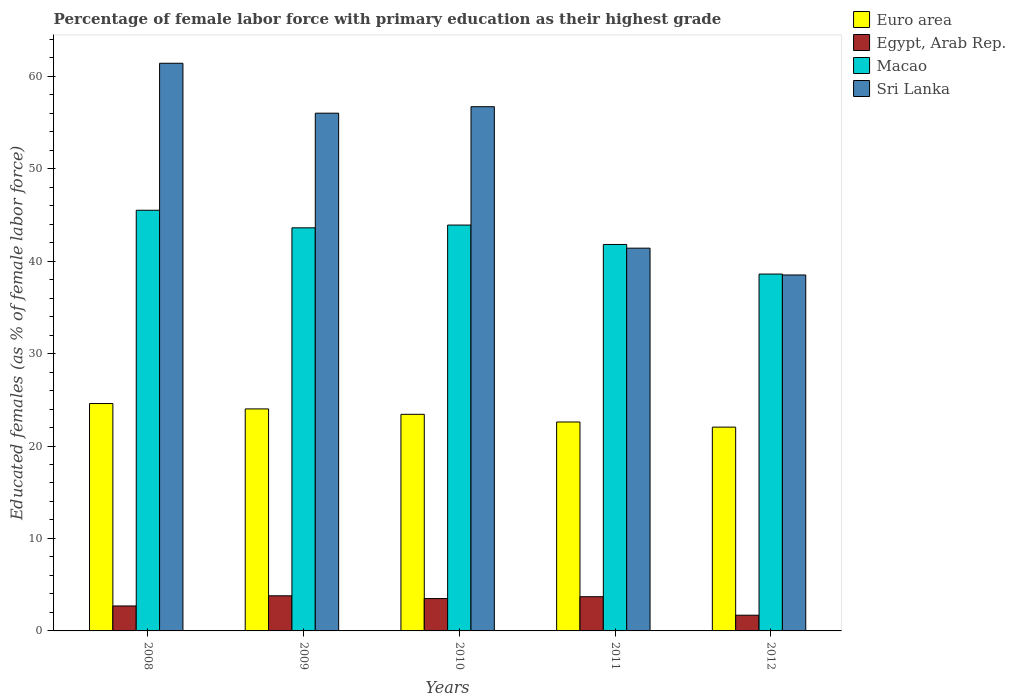How many different coloured bars are there?
Offer a very short reply. 4. Are the number of bars on each tick of the X-axis equal?
Your answer should be compact. Yes. What is the label of the 3rd group of bars from the left?
Your answer should be compact. 2010. What is the percentage of female labor force with primary education in Egypt, Arab Rep. in 2011?
Your answer should be compact. 3.7. Across all years, what is the maximum percentage of female labor force with primary education in Sri Lanka?
Ensure brevity in your answer.  61.4. Across all years, what is the minimum percentage of female labor force with primary education in Euro area?
Provide a short and direct response. 22.04. In which year was the percentage of female labor force with primary education in Egypt, Arab Rep. maximum?
Your response must be concise. 2009. In which year was the percentage of female labor force with primary education in Sri Lanka minimum?
Give a very brief answer. 2012. What is the total percentage of female labor force with primary education in Euro area in the graph?
Give a very brief answer. 116.68. What is the difference between the percentage of female labor force with primary education in Macao in 2009 and that in 2011?
Offer a terse response. 1.8. What is the difference between the percentage of female labor force with primary education in Sri Lanka in 2011 and the percentage of female labor force with primary education in Macao in 2008?
Your response must be concise. -4.1. What is the average percentage of female labor force with primary education in Macao per year?
Keep it short and to the point. 42.68. In the year 2012, what is the difference between the percentage of female labor force with primary education in Euro area and percentage of female labor force with primary education in Egypt, Arab Rep.?
Provide a succinct answer. 20.34. In how many years, is the percentage of female labor force with primary education in Sri Lanka greater than 40 %?
Offer a terse response. 4. What is the ratio of the percentage of female labor force with primary education in Macao in 2011 to that in 2012?
Your response must be concise. 1.08. Is the percentage of female labor force with primary education in Sri Lanka in 2010 less than that in 2012?
Provide a succinct answer. No. Is the difference between the percentage of female labor force with primary education in Euro area in 2010 and 2012 greater than the difference between the percentage of female labor force with primary education in Egypt, Arab Rep. in 2010 and 2012?
Provide a short and direct response. No. What is the difference between the highest and the second highest percentage of female labor force with primary education in Macao?
Keep it short and to the point. 1.6. What is the difference between the highest and the lowest percentage of female labor force with primary education in Sri Lanka?
Offer a very short reply. 22.9. Is the sum of the percentage of female labor force with primary education in Sri Lanka in 2009 and 2011 greater than the maximum percentage of female labor force with primary education in Egypt, Arab Rep. across all years?
Your answer should be very brief. Yes. Is it the case that in every year, the sum of the percentage of female labor force with primary education in Sri Lanka and percentage of female labor force with primary education in Euro area is greater than the percentage of female labor force with primary education in Egypt, Arab Rep.?
Offer a terse response. Yes. Are all the bars in the graph horizontal?
Provide a succinct answer. No. How many years are there in the graph?
Ensure brevity in your answer.  5. How many legend labels are there?
Your answer should be very brief. 4. How are the legend labels stacked?
Give a very brief answer. Vertical. What is the title of the graph?
Ensure brevity in your answer.  Percentage of female labor force with primary education as their highest grade. What is the label or title of the Y-axis?
Provide a short and direct response. Educated females (as % of female labor force). What is the Educated females (as % of female labor force) in Euro area in 2008?
Give a very brief answer. 24.59. What is the Educated females (as % of female labor force) of Egypt, Arab Rep. in 2008?
Your answer should be very brief. 2.7. What is the Educated females (as % of female labor force) in Macao in 2008?
Offer a very short reply. 45.5. What is the Educated females (as % of female labor force) of Sri Lanka in 2008?
Give a very brief answer. 61.4. What is the Educated females (as % of female labor force) in Euro area in 2009?
Your answer should be very brief. 24.01. What is the Educated females (as % of female labor force) of Egypt, Arab Rep. in 2009?
Provide a succinct answer. 3.8. What is the Educated females (as % of female labor force) in Macao in 2009?
Offer a very short reply. 43.6. What is the Educated females (as % of female labor force) in Euro area in 2010?
Offer a very short reply. 23.43. What is the Educated females (as % of female labor force) in Macao in 2010?
Ensure brevity in your answer.  43.9. What is the Educated females (as % of female labor force) of Sri Lanka in 2010?
Give a very brief answer. 56.7. What is the Educated females (as % of female labor force) of Euro area in 2011?
Provide a short and direct response. 22.6. What is the Educated females (as % of female labor force) in Egypt, Arab Rep. in 2011?
Keep it short and to the point. 3.7. What is the Educated females (as % of female labor force) in Macao in 2011?
Give a very brief answer. 41.8. What is the Educated females (as % of female labor force) of Sri Lanka in 2011?
Provide a short and direct response. 41.4. What is the Educated females (as % of female labor force) of Euro area in 2012?
Your response must be concise. 22.04. What is the Educated females (as % of female labor force) of Egypt, Arab Rep. in 2012?
Your answer should be very brief. 1.7. What is the Educated females (as % of female labor force) of Macao in 2012?
Offer a terse response. 38.6. What is the Educated females (as % of female labor force) of Sri Lanka in 2012?
Offer a very short reply. 38.5. Across all years, what is the maximum Educated females (as % of female labor force) in Euro area?
Give a very brief answer. 24.59. Across all years, what is the maximum Educated females (as % of female labor force) of Egypt, Arab Rep.?
Offer a terse response. 3.8. Across all years, what is the maximum Educated females (as % of female labor force) in Macao?
Offer a terse response. 45.5. Across all years, what is the maximum Educated females (as % of female labor force) of Sri Lanka?
Your response must be concise. 61.4. Across all years, what is the minimum Educated females (as % of female labor force) in Euro area?
Keep it short and to the point. 22.04. Across all years, what is the minimum Educated females (as % of female labor force) of Egypt, Arab Rep.?
Your answer should be very brief. 1.7. Across all years, what is the minimum Educated females (as % of female labor force) of Macao?
Offer a very short reply. 38.6. Across all years, what is the minimum Educated females (as % of female labor force) of Sri Lanka?
Provide a short and direct response. 38.5. What is the total Educated females (as % of female labor force) of Euro area in the graph?
Make the answer very short. 116.68. What is the total Educated females (as % of female labor force) of Macao in the graph?
Your answer should be very brief. 213.4. What is the total Educated females (as % of female labor force) of Sri Lanka in the graph?
Provide a short and direct response. 254. What is the difference between the Educated females (as % of female labor force) in Euro area in 2008 and that in 2009?
Your response must be concise. 0.58. What is the difference between the Educated females (as % of female labor force) in Egypt, Arab Rep. in 2008 and that in 2009?
Your answer should be very brief. -1.1. What is the difference between the Educated females (as % of female labor force) of Macao in 2008 and that in 2009?
Ensure brevity in your answer.  1.9. What is the difference between the Educated females (as % of female labor force) of Sri Lanka in 2008 and that in 2009?
Ensure brevity in your answer.  5.4. What is the difference between the Educated females (as % of female labor force) of Euro area in 2008 and that in 2010?
Your answer should be compact. 1.17. What is the difference between the Educated females (as % of female labor force) in Egypt, Arab Rep. in 2008 and that in 2010?
Ensure brevity in your answer.  -0.8. What is the difference between the Educated females (as % of female labor force) of Euro area in 2008 and that in 2011?
Keep it short and to the point. 1.99. What is the difference between the Educated females (as % of female labor force) in Egypt, Arab Rep. in 2008 and that in 2011?
Keep it short and to the point. -1. What is the difference between the Educated females (as % of female labor force) of Macao in 2008 and that in 2011?
Ensure brevity in your answer.  3.7. What is the difference between the Educated females (as % of female labor force) in Sri Lanka in 2008 and that in 2011?
Give a very brief answer. 20. What is the difference between the Educated females (as % of female labor force) in Euro area in 2008 and that in 2012?
Provide a short and direct response. 2.55. What is the difference between the Educated females (as % of female labor force) of Egypt, Arab Rep. in 2008 and that in 2012?
Offer a terse response. 1. What is the difference between the Educated females (as % of female labor force) of Sri Lanka in 2008 and that in 2012?
Ensure brevity in your answer.  22.9. What is the difference between the Educated females (as % of female labor force) in Euro area in 2009 and that in 2010?
Offer a very short reply. 0.58. What is the difference between the Educated females (as % of female labor force) of Egypt, Arab Rep. in 2009 and that in 2010?
Offer a very short reply. 0.3. What is the difference between the Educated females (as % of female labor force) in Euro area in 2009 and that in 2011?
Offer a terse response. 1.41. What is the difference between the Educated females (as % of female labor force) in Egypt, Arab Rep. in 2009 and that in 2011?
Keep it short and to the point. 0.1. What is the difference between the Educated females (as % of female labor force) in Macao in 2009 and that in 2011?
Your answer should be very brief. 1.8. What is the difference between the Educated females (as % of female labor force) in Sri Lanka in 2009 and that in 2011?
Make the answer very short. 14.6. What is the difference between the Educated females (as % of female labor force) in Euro area in 2009 and that in 2012?
Your answer should be very brief. 1.97. What is the difference between the Educated females (as % of female labor force) in Egypt, Arab Rep. in 2009 and that in 2012?
Give a very brief answer. 2.1. What is the difference between the Educated females (as % of female labor force) of Sri Lanka in 2009 and that in 2012?
Give a very brief answer. 17.5. What is the difference between the Educated females (as % of female labor force) in Euro area in 2010 and that in 2011?
Provide a short and direct response. 0.83. What is the difference between the Educated females (as % of female labor force) in Euro area in 2010 and that in 2012?
Ensure brevity in your answer.  1.38. What is the difference between the Educated females (as % of female labor force) in Sri Lanka in 2010 and that in 2012?
Offer a terse response. 18.2. What is the difference between the Educated females (as % of female labor force) in Euro area in 2011 and that in 2012?
Keep it short and to the point. 0.55. What is the difference between the Educated females (as % of female labor force) of Sri Lanka in 2011 and that in 2012?
Keep it short and to the point. 2.9. What is the difference between the Educated females (as % of female labor force) of Euro area in 2008 and the Educated females (as % of female labor force) of Egypt, Arab Rep. in 2009?
Your answer should be very brief. 20.79. What is the difference between the Educated females (as % of female labor force) in Euro area in 2008 and the Educated females (as % of female labor force) in Macao in 2009?
Make the answer very short. -19.01. What is the difference between the Educated females (as % of female labor force) of Euro area in 2008 and the Educated females (as % of female labor force) of Sri Lanka in 2009?
Give a very brief answer. -31.41. What is the difference between the Educated females (as % of female labor force) of Egypt, Arab Rep. in 2008 and the Educated females (as % of female labor force) of Macao in 2009?
Your answer should be very brief. -40.9. What is the difference between the Educated females (as % of female labor force) in Egypt, Arab Rep. in 2008 and the Educated females (as % of female labor force) in Sri Lanka in 2009?
Your answer should be very brief. -53.3. What is the difference between the Educated females (as % of female labor force) of Euro area in 2008 and the Educated females (as % of female labor force) of Egypt, Arab Rep. in 2010?
Your response must be concise. 21.09. What is the difference between the Educated females (as % of female labor force) of Euro area in 2008 and the Educated females (as % of female labor force) of Macao in 2010?
Your response must be concise. -19.31. What is the difference between the Educated females (as % of female labor force) of Euro area in 2008 and the Educated females (as % of female labor force) of Sri Lanka in 2010?
Provide a succinct answer. -32.11. What is the difference between the Educated females (as % of female labor force) of Egypt, Arab Rep. in 2008 and the Educated females (as % of female labor force) of Macao in 2010?
Provide a short and direct response. -41.2. What is the difference between the Educated females (as % of female labor force) of Egypt, Arab Rep. in 2008 and the Educated females (as % of female labor force) of Sri Lanka in 2010?
Offer a terse response. -54. What is the difference between the Educated females (as % of female labor force) in Macao in 2008 and the Educated females (as % of female labor force) in Sri Lanka in 2010?
Your answer should be compact. -11.2. What is the difference between the Educated females (as % of female labor force) of Euro area in 2008 and the Educated females (as % of female labor force) of Egypt, Arab Rep. in 2011?
Offer a very short reply. 20.89. What is the difference between the Educated females (as % of female labor force) in Euro area in 2008 and the Educated females (as % of female labor force) in Macao in 2011?
Offer a very short reply. -17.21. What is the difference between the Educated females (as % of female labor force) of Euro area in 2008 and the Educated females (as % of female labor force) of Sri Lanka in 2011?
Offer a terse response. -16.81. What is the difference between the Educated females (as % of female labor force) in Egypt, Arab Rep. in 2008 and the Educated females (as % of female labor force) in Macao in 2011?
Give a very brief answer. -39.1. What is the difference between the Educated females (as % of female labor force) in Egypt, Arab Rep. in 2008 and the Educated females (as % of female labor force) in Sri Lanka in 2011?
Provide a short and direct response. -38.7. What is the difference between the Educated females (as % of female labor force) of Euro area in 2008 and the Educated females (as % of female labor force) of Egypt, Arab Rep. in 2012?
Ensure brevity in your answer.  22.89. What is the difference between the Educated females (as % of female labor force) of Euro area in 2008 and the Educated females (as % of female labor force) of Macao in 2012?
Provide a short and direct response. -14.01. What is the difference between the Educated females (as % of female labor force) of Euro area in 2008 and the Educated females (as % of female labor force) of Sri Lanka in 2012?
Provide a succinct answer. -13.91. What is the difference between the Educated females (as % of female labor force) in Egypt, Arab Rep. in 2008 and the Educated females (as % of female labor force) in Macao in 2012?
Keep it short and to the point. -35.9. What is the difference between the Educated females (as % of female labor force) of Egypt, Arab Rep. in 2008 and the Educated females (as % of female labor force) of Sri Lanka in 2012?
Your response must be concise. -35.8. What is the difference between the Educated females (as % of female labor force) of Macao in 2008 and the Educated females (as % of female labor force) of Sri Lanka in 2012?
Keep it short and to the point. 7. What is the difference between the Educated females (as % of female labor force) in Euro area in 2009 and the Educated females (as % of female labor force) in Egypt, Arab Rep. in 2010?
Keep it short and to the point. 20.51. What is the difference between the Educated females (as % of female labor force) in Euro area in 2009 and the Educated females (as % of female labor force) in Macao in 2010?
Your answer should be very brief. -19.89. What is the difference between the Educated females (as % of female labor force) of Euro area in 2009 and the Educated females (as % of female labor force) of Sri Lanka in 2010?
Your answer should be very brief. -32.69. What is the difference between the Educated females (as % of female labor force) in Egypt, Arab Rep. in 2009 and the Educated females (as % of female labor force) in Macao in 2010?
Give a very brief answer. -40.1. What is the difference between the Educated females (as % of female labor force) in Egypt, Arab Rep. in 2009 and the Educated females (as % of female labor force) in Sri Lanka in 2010?
Give a very brief answer. -52.9. What is the difference between the Educated females (as % of female labor force) in Macao in 2009 and the Educated females (as % of female labor force) in Sri Lanka in 2010?
Your answer should be very brief. -13.1. What is the difference between the Educated females (as % of female labor force) in Euro area in 2009 and the Educated females (as % of female labor force) in Egypt, Arab Rep. in 2011?
Offer a terse response. 20.31. What is the difference between the Educated females (as % of female labor force) of Euro area in 2009 and the Educated females (as % of female labor force) of Macao in 2011?
Provide a succinct answer. -17.79. What is the difference between the Educated females (as % of female labor force) in Euro area in 2009 and the Educated females (as % of female labor force) in Sri Lanka in 2011?
Offer a very short reply. -17.39. What is the difference between the Educated females (as % of female labor force) of Egypt, Arab Rep. in 2009 and the Educated females (as % of female labor force) of Macao in 2011?
Your response must be concise. -38. What is the difference between the Educated females (as % of female labor force) in Egypt, Arab Rep. in 2009 and the Educated females (as % of female labor force) in Sri Lanka in 2011?
Your answer should be compact. -37.6. What is the difference between the Educated females (as % of female labor force) of Euro area in 2009 and the Educated females (as % of female labor force) of Egypt, Arab Rep. in 2012?
Your answer should be very brief. 22.31. What is the difference between the Educated females (as % of female labor force) in Euro area in 2009 and the Educated females (as % of female labor force) in Macao in 2012?
Your answer should be compact. -14.59. What is the difference between the Educated females (as % of female labor force) of Euro area in 2009 and the Educated females (as % of female labor force) of Sri Lanka in 2012?
Ensure brevity in your answer.  -14.49. What is the difference between the Educated females (as % of female labor force) in Egypt, Arab Rep. in 2009 and the Educated females (as % of female labor force) in Macao in 2012?
Your answer should be compact. -34.8. What is the difference between the Educated females (as % of female labor force) of Egypt, Arab Rep. in 2009 and the Educated females (as % of female labor force) of Sri Lanka in 2012?
Offer a terse response. -34.7. What is the difference between the Educated females (as % of female labor force) in Euro area in 2010 and the Educated females (as % of female labor force) in Egypt, Arab Rep. in 2011?
Provide a short and direct response. 19.73. What is the difference between the Educated females (as % of female labor force) in Euro area in 2010 and the Educated females (as % of female labor force) in Macao in 2011?
Your response must be concise. -18.37. What is the difference between the Educated females (as % of female labor force) of Euro area in 2010 and the Educated females (as % of female labor force) of Sri Lanka in 2011?
Give a very brief answer. -17.97. What is the difference between the Educated females (as % of female labor force) of Egypt, Arab Rep. in 2010 and the Educated females (as % of female labor force) of Macao in 2011?
Offer a very short reply. -38.3. What is the difference between the Educated females (as % of female labor force) of Egypt, Arab Rep. in 2010 and the Educated females (as % of female labor force) of Sri Lanka in 2011?
Offer a terse response. -37.9. What is the difference between the Educated females (as % of female labor force) in Euro area in 2010 and the Educated females (as % of female labor force) in Egypt, Arab Rep. in 2012?
Keep it short and to the point. 21.73. What is the difference between the Educated females (as % of female labor force) of Euro area in 2010 and the Educated females (as % of female labor force) of Macao in 2012?
Offer a very short reply. -15.17. What is the difference between the Educated females (as % of female labor force) of Euro area in 2010 and the Educated females (as % of female labor force) of Sri Lanka in 2012?
Make the answer very short. -15.07. What is the difference between the Educated females (as % of female labor force) of Egypt, Arab Rep. in 2010 and the Educated females (as % of female labor force) of Macao in 2012?
Provide a succinct answer. -35.1. What is the difference between the Educated females (as % of female labor force) of Egypt, Arab Rep. in 2010 and the Educated females (as % of female labor force) of Sri Lanka in 2012?
Provide a short and direct response. -35. What is the difference between the Educated females (as % of female labor force) in Euro area in 2011 and the Educated females (as % of female labor force) in Egypt, Arab Rep. in 2012?
Your response must be concise. 20.9. What is the difference between the Educated females (as % of female labor force) of Euro area in 2011 and the Educated females (as % of female labor force) of Macao in 2012?
Ensure brevity in your answer.  -16. What is the difference between the Educated females (as % of female labor force) in Euro area in 2011 and the Educated females (as % of female labor force) in Sri Lanka in 2012?
Give a very brief answer. -15.9. What is the difference between the Educated females (as % of female labor force) of Egypt, Arab Rep. in 2011 and the Educated females (as % of female labor force) of Macao in 2012?
Your response must be concise. -34.9. What is the difference between the Educated females (as % of female labor force) in Egypt, Arab Rep. in 2011 and the Educated females (as % of female labor force) in Sri Lanka in 2012?
Give a very brief answer. -34.8. What is the average Educated females (as % of female labor force) of Euro area per year?
Your answer should be very brief. 23.34. What is the average Educated females (as % of female labor force) of Egypt, Arab Rep. per year?
Give a very brief answer. 3.08. What is the average Educated females (as % of female labor force) in Macao per year?
Make the answer very short. 42.68. What is the average Educated females (as % of female labor force) of Sri Lanka per year?
Offer a terse response. 50.8. In the year 2008, what is the difference between the Educated females (as % of female labor force) of Euro area and Educated females (as % of female labor force) of Egypt, Arab Rep.?
Provide a succinct answer. 21.89. In the year 2008, what is the difference between the Educated females (as % of female labor force) in Euro area and Educated females (as % of female labor force) in Macao?
Your answer should be very brief. -20.91. In the year 2008, what is the difference between the Educated females (as % of female labor force) of Euro area and Educated females (as % of female labor force) of Sri Lanka?
Keep it short and to the point. -36.81. In the year 2008, what is the difference between the Educated females (as % of female labor force) in Egypt, Arab Rep. and Educated females (as % of female labor force) in Macao?
Your answer should be compact. -42.8. In the year 2008, what is the difference between the Educated females (as % of female labor force) of Egypt, Arab Rep. and Educated females (as % of female labor force) of Sri Lanka?
Your answer should be very brief. -58.7. In the year 2008, what is the difference between the Educated females (as % of female labor force) in Macao and Educated females (as % of female labor force) in Sri Lanka?
Your answer should be compact. -15.9. In the year 2009, what is the difference between the Educated females (as % of female labor force) of Euro area and Educated females (as % of female labor force) of Egypt, Arab Rep.?
Ensure brevity in your answer.  20.21. In the year 2009, what is the difference between the Educated females (as % of female labor force) of Euro area and Educated females (as % of female labor force) of Macao?
Keep it short and to the point. -19.59. In the year 2009, what is the difference between the Educated females (as % of female labor force) in Euro area and Educated females (as % of female labor force) in Sri Lanka?
Provide a succinct answer. -31.99. In the year 2009, what is the difference between the Educated females (as % of female labor force) of Egypt, Arab Rep. and Educated females (as % of female labor force) of Macao?
Offer a very short reply. -39.8. In the year 2009, what is the difference between the Educated females (as % of female labor force) of Egypt, Arab Rep. and Educated females (as % of female labor force) of Sri Lanka?
Keep it short and to the point. -52.2. In the year 2010, what is the difference between the Educated females (as % of female labor force) of Euro area and Educated females (as % of female labor force) of Egypt, Arab Rep.?
Give a very brief answer. 19.93. In the year 2010, what is the difference between the Educated females (as % of female labor force) of Euro area and Educated females (as % of female labor force) of Macao?
Offer a terse response. -20.47. In the year 2010, what is the difference between the Educated females (as % of female labor force) in Euro area and Educated females (as % of female labor force) in Sri Lanka?
Provide a succinct answer. -33.27. In the year 2010, what is the difference between the Educated females (as % of female labor force) of Egypt, Arab Rep. and Educated females (as % of female labor force) of Macao?
Provide a short and direct response. -40.4. In the year 2010, what is the difference between the Educated females (as % of female labor force) of Egypt, Arab Rep. and Educated females (as % of female labor force) of Sri Lanka?
Provide a short and direct response. -53.2. In the year 2010, what is the difference between the Educated females (as % of female labor force) in Macao and Educated females (as % of female labor force) in Sri Lanka?
Provide a short and direct response. -12.8. In the year 2011, what is the difference between the Educated females (as % of female labor force) of Euro area and Educated females (as % of female labor force) of Egypt, Arab Rep.?
Ensure brevity in your answer.  18.9. In the year 2011, what is the difference between the Educated females (as % of female labor force) in Euro area and Educated females (as % of female labor force) in Macao?
Keep it short and to the point. -19.2. In the year 2011, what is the difference between the Educated females (as % of female labor force) of Euro area and Educated females (as % of female labor force) of Sri Lanka?
Offer a terse response. -18.8. In the year 2011, what is the difference between the Educated females (as % of female labor force) in Egypt, Arab Rep. and Educated females (as % of female labor force) in Macao?
Offer a very short reply. -38.1. In the year 2011, what is the difference between the Educated females (as % of female labor force) of Egypt, Arab Rep. and Educated females (as % of female labor force) of Sri Lanka?
Your answer should be very brief. -37.7. In the year 2012, what is the difference between the Educated females (as % of female labor force) of Euro area and Educated females (as % of female labor force) of Egypt, Arab Rep.?
Offer a very short reply. 20.34. In the year 2012, what is the difference between the Educated females (as % of female labor force) in Euro area and Educated females (as % of female labor force) in Macao?
Give a very brief answer. -16.56. In the year 2012, what is the difference between the Educated females (as % of female labor force) of Euro area and Educated females (as % of female labor force) of Sri Lanka?
Make the answer very short. -16.46. In the year 2012, what is the difference between the Educated females (as % of female labor force) in Egypt, Arab Rep. and Educated females (as % of female labor force) in Macao?
Offer a terse response. -36.9. In the year 2012, what is the difference between the Educated females (as % of female labor force) of Egypt, Arab Rep. and Educated females (as % of female labor force) of Sri Lanka?
Give a very brief answer. -36.8. What is the ratio of the Educated females (as % of female labor force) of Euro area in 2008 to that in 2009?
Ensure brevity in your answer.  1.02. What is the ratio of the Educated females (as % of female labor force) of Egypt, Arab Rep. in 2008 to that in 2009?
Offer a terse response. 0.71. What is the ratio of the Educated females (as % of female labor force) of Macao in 2008 to that in 2009?
Provide a short and direct response. 1.04. What is the ratio of the Educated females (as % of female labor force) in Sri Lanka in 2008 to that in 2009?
Your answer should be compact. 1.1. What is the ratio of the Educated females (as % of female labor force) of Euro area in 2008 to that in 2010?
Your answer should be very brief. 1.05. What is the ratio of the Educated females (as % of female labor force) of Egypt, Arab Rep. in 2008 to that in 2010?
Your response must be concise. 0.77. What is the ratio of the Educated females (as % of female labor force) in Macao in 2008 to that in 2010?
Keep it short and to the point. 1.04. What is the ratio of the Educated females (as % of female labor force) of Sri Lanka in 2008 to that in 2010?
Make the answer very short. 1.08. What is the ratio of the Educated females (as % of female labor force) in Euro area in 2008 to that in 2011?
Your answer should be compact. 1.09. What is the ratio of the Educated females (as % of female labor force) in Egypt, Arab Rep. in 2008 to that in 2011?
Give a very brief answer. 0.73. What is the ratio of the Educated females (as % of female labor force) of Macao in 2008 to that in 2011?
Keep it short and to the point. 1.09. What is the ratio of the Educated females (as % of female labor force) in Sri Lanka in 2008 to that in 2011?
Offer a terse response. 1.48. What is the ratio of the Educated females (as % of female labor force) of Euro area in 2008 to that in 2012?
Give a very brief answer. 1.12. What is the ratio of the Educated females (as % of female labor force) of Egypt, Arab Rep. in 2008 to that in 2012?
Provide a succinct answer. 1.59. What is the ratio of the Educated females (as % of female labor force) of Macao in 2008 to that in 2012?
Ensure brevity in your answer.  1.18. What is the ratio of the Educated females (as % of female labor force) of Sri Lanka in 2008 to that in 2012?
Keep it short and to the point. 1.59. What is the ratio of the Educated females (as % of female labor force) in Euro area in 2009 to that in 2010?
Provide a short and direct response. 1.02. What is the ratio of the Educated females (as % of female labor force) in Egypt, Arab Rep. in 2009 to that in 2010?
Provide a succinct answer. 1.09. What is the ratio of the Educated females (as % of female labor force) of Macao in 2009 to that in 2010?
Your answer should be compact. 0.99. What is the ratio of the Educated females (as % of female labor force) of Euro area in 2009 to that in 2011?
Provide a succinct answer. 1.06. What is the ratio of the Educated females (as % of female labor force) in Macao in 2009 to that in 2011?
Give a very brief answer. 1.04. What is the ratio of the Educated females (as % of female labor force) in Sri Lanka in 2009 to that in 2011?
Your response must be concise. 1.35. What is the ratio of the Educated females (as % of female labor force) of Euro area in 2009 to that in 2012?
Your response must be concise. 1.09. What is the ratio of the Educated females (as % of female labor force) in Egypt, Arab Rep. in 2009 to that in 2012?
Provide a short and direct response. 2.24. What is the ratio of the Educated females (as % of female labor force) of Macao in 2009 to that in 2012?
Ensure brevity in your answer.  1.13. What is the ratio of the Educated females (as % of female labor force) of Sri Lanka in 2009 to that in 2012?
Keep it short and to the point. 1.45. What is the ratio of the Educated females (as % of female labor force) in Euro area in 2010 to that in 2011?
Your answer should be compact. 1.04. What is the ratio of the Educated females (as % of female labor force) of Egypt, Arab Rep. in 2010 to that in 2011?
Provide a short and direct response. 0.95. What is the ratio of the Educated females (as % of female labor force) in Macao in 2010 to that in 2011?
Give a very brief answer. 1.05. What is the ratio of the Educated females (as % of female labor force) in Sri Lanka in 2010 to that in 2011?
Provide a short and direct response. 1.37. What is the ratio of the Educated females (as % of female labor force) in Euro area in 2010 to that in 2012?
Provide a short and direct response. 1.06. What is the ratio of the Educated females (as % of female labor force) of Egypt, Arab Rep. in 2010 to that in 2012?
Offer a terse response. 2.06. What is the ratio of the Educated females (as % of female labor force) of Macao in 2010 to that in 2012?
Provide a short and direct response. 1.14. What is the ratio of the Educated females (as % of female labor force) of Sri Lanka in 2010 to that in 2012?
Make the answer very short. 1.47. What is the ratio of the Educated females (as % of female labor force) of Euro area in 2011 to that in 2012?
Your response must be concise. 1.03. What is the ratio of the Educated females (as % of female labor force) in Egypt, Arab Rep. in 2011 to that in 2012?
Keep it short and to the point. 2.18. What is the ratio of the Educated females (as % of female labor force) in Macao in 2011 to that in 2012?
Your answer should be compact. 1.08. What is the ratio of the Educated females (as % of female labor force) of Sri Lanka in 2011 to that in 2012?
Offer a very short reply. 1.08. What is the difference between the highest and the second highest Educated females (as % of female labor force) of Euro area?
Make the answer very short. 0.58. What is the difference between the highest and the second highest Educated females (as % of female labor force) in Egypt, Arab Rep.?
Offer a terse response. 0.1. What is the difference between the highest and the lowest Educated females (as % of female labor force) of Euro area?
Your response must be concise. 2.55. What is the difference between the highest and the lowest Educated females (as % of female labor force) in Macao?
Give a very brief answer. 6.9. What is the difference between the highest and the lowest Educated females (as % of female labor force) in Sri Lanka?
Provide a short and direct response. 22.9. 